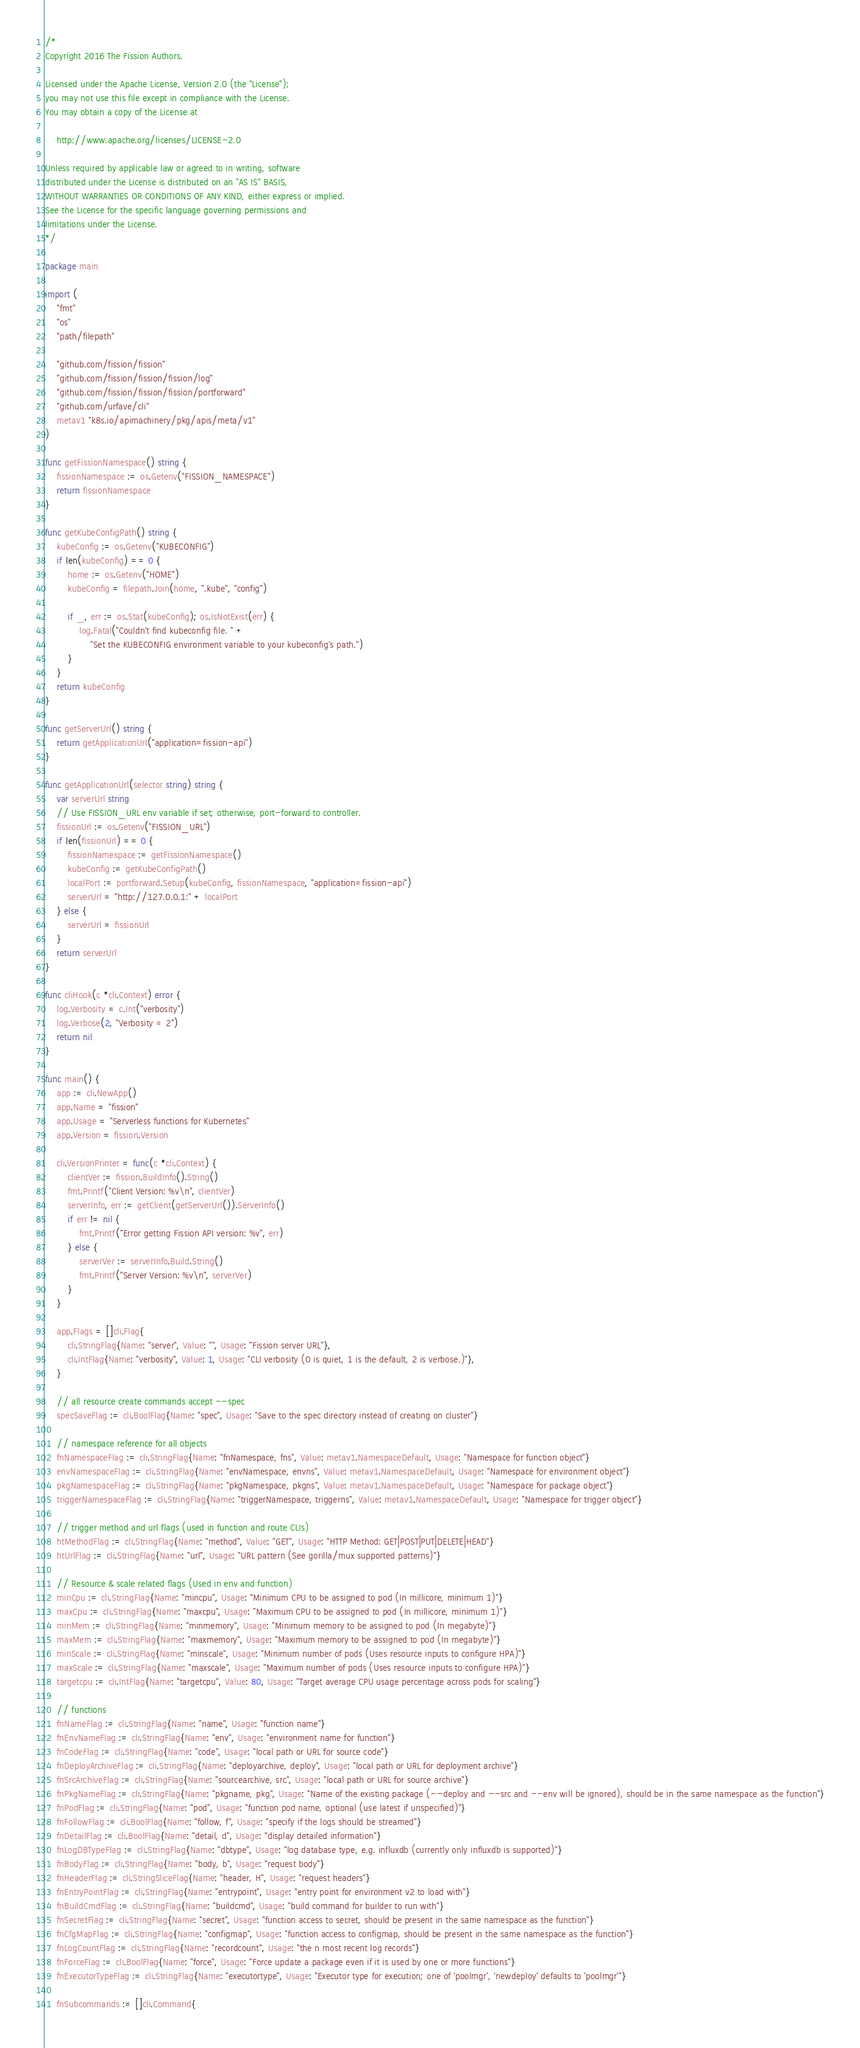<code> <loc_0><loc_0><loc_500><loc_500><_Go_>/*
Copyright 2016 The Fission Authors.

Licensed under the Apache License, Version 2.0 (the "License");
you may not use this file except in compliance with the License.
You may obtain a copy of the License at

    http://www.apache.org/licenses/LICENSE-2.0

Unless required by applicable law or agreed to in writing, software
distributed under the License is distributed on an "AS IS" BASIS,
WITHOUT WARRANTIES OR CONDITIONS OF ANY KIND, either express or implied.
See the License for the specific language governing permissions and
limitations under the License.
*/

package main

import (
	"fmt"
	"os"
	"path/filepath"

	"github.com/fission/fission"
	"github.com/fission/fission/fission/log"
	"github.com/fission/fission/fission/portforward"
	"github.com/urfave/cli"
	metav1 "k8s.io/apimachinery/pkg/apis/meta/v1"
)

func getFissionNamespace() string {
	fissionNamespace := os.Getenv("FISSION_NAMESPACE")
	return fissionNamespace
}

func getKubeConfigPath() string {
	kubeConfig := os.Getenv("KUBECONFIG")
	if len(kubeConfig) == 0 {
		home := os.Getenv("HOME")
		kubeConfig = filepath.Join(home, ".kube", "config")

		if _, err := os.Stat(kubeConfig); os.IsNotExist(err) {
			log.Fatal("Couldn't find kubeconfig file. " +
				"Set the KUBECONFIG environment variable to your kubeconfig's path.")
		}
	}
	return kubeConfig
}

func getServerUrl() string {
	return getApplicationUrl("application=fission-api")
}

func getApplicationUrl(selector string) string {
	var serverUrl string
	// Use FISSION_URL env variable if set; otherwise, port-forward to controller.
	fissionUrl := os.Getenv("FISSION_URL")
	if len(fissionUrl) == 0 {
		fissionNamespace := getFissionNamespace()
		kubeConfig := getKubeConfigPath()
		localPort := portforward.Setup(kubeConfig, fissionNamespace, "application=fission-api")
		serverUrl = "http://127.0.0.1:" + localPort
	} else {
		serverUrl = fissionUrl
	}
	return serverUrl
}

func cliHook(c *cli.Context) error {
	log.Verbosity = c.Int("verbosity")
	log.Verbose(2, "Verbosity = 2")
	return nil
}

func main() {
	app := cli.NewApp()
	app.Name = "fission"
	app.Usage = "Serverless functions for Kubernetes"
	app.Version = fission.Version

	cli.VersionPrinter = func(c *cli.Context) {
		clientVer := fission.BuildInfo().String()
		fmt.Printf("Client Version: %v\n", clientVer)
		serverInfo, err := getClient(getServerUrl()).ServerInfo()
		if err != nil {
			fmt.Printf("Error getting Fission API version: %v", err)
		} else {
			serverVer := serverInfo.Build.String()
			fmt.Printf("Server Version: %v\n", serverVer)
		}
	}

	app.Flags = []cli.Flag{
		cli.StringFlag{Name: "server", Value: "", Usage: "Fission server URL"},
		cli.IntFlag{Name: "verbosity", Value: 1, Usage: "CLI verbosity (0 is quiet, 1 is the default, 2 is verbose.)"},
	}

	// all resource create commands accept --spec
	specSaveFlag := cli.BoolFlag{Name: "spec", Usage: "Save to the spec directory instead of creating on cluster"}

	// namespace reference for all objects
	fnNamespaceFlag := cli.StringFlag{Name: "fnNamespace, fns", Value: metav1.NamespaceDefault, Usage: "Namespace for function object"}
	envNamespaceFlag := cli.StringFlag{Name: "envNamespace, envns", Value: metav1.NamespaceDefault, Usage: "Namespace for environment object"}
	pkgNamespaceFlag := cli.StringFlag{Name: "pkgNamespace, pkgns", Value: metav1.NamespaceDefault, Usage: "Namespace for package object"}
	triggerNamespaceFlag := cli.StringFlag{Name: "triggerNamespace, triggerns", Value: metav1.NamespaceDefault, Usage: "Namespace for trigger object"}

	// trigger method and url flags (used in function and route CLIs)
	htMethodFlag := cli.StringFlag{Name: "method", Value: "GET", Usage: "HTTP Method: GET|POST|PUT|DELETE|HEAD"}
	htUrlFlag := cli.StringFlag{Name: "url", Usage: "URL pattern (See gorilla/mux supported patterns)"}

	// Resource & scale related flags (Used in env and function)
	minCpu := cli.StringFlag{Name: "mincpu", Usage: "Minimum CPU to be assigned to pod (In millicore, minimum 1)"}
	maxCpu := cli.StringFlag{Name: "maxcpu", Usage: "Maximum CPU to be assigned to pod (In millicore, minimum 1)"}
	minMem := cli.StringFlag{Name: "minmemory", Usage: "Minimum memory to be assigned to pod (In megabyte)"}
	maxMem := cli.StringFlag{Name: "maxmemory", Usage: "Maximum memory to be assigned to pod (In megabyte)"}
	minScale := cli.StringFlag{Name: "minscale", Usage: "Minimum number of pods (Uses resource inputs to configure HPA)"}
	maxScale := cli.StringFlag{Name: "maxscale", Usage: "Maximum number of pods (Uses resource inputs to configure HPA)"}
	targetcpu := cli.IntFlag{Name: "targetcpu", Value: 80, Usage: "Target average CPU usage percentage across pods for scaling"}

	// functions
	fnNameFlag := cli.StringFlag{Name: "name", Usage: "function name"}
	fnEnvNameFlag := cli.StringFlag{Name: "env", Usage: "environment name for function"}
	fnCodeFlag := cli.StringFlag{Name: "code", Usage: "local path or URL for source code"}
	fnDeployArchiveFlag := cli.StringFlag{Name: "deployarchive, deploy", Usage: "local path or URL for deployment archive"}
	fnSrcArchiveFlag := cli.StringFlag{Name: "sourcearchive, src", Usage: "local path or URL for source archive"}
	fnPkgNameFlag := cli.StringFlag{Name: "pkgname, pkg", Usage: "Name of the existing package (--deploy and --src and --env will be ignored), should be in the same namespace as the function"}
	fnPodFlag := cli.StringFlag{Name: "pod", Usage: "function pod name, optional (use latest if unspecified)"}
	fnFollowFlag := cli.BoolFlag{Name: "follow, f", Usage: "specify if the logs should be streamed"}
	fnDetailFlag := cli.BoolFlag{Name: "detail, d", Usage: "display detailed information"}
	fnLogDBTypeFlag := cli.StringFlag{Name: "dbtype", Usage: "log database type, e.g. influxdb (currently only influxdb is supported)"}
	fnBodyFlag := cli.StringFlag{Name: "body, b", Usage: "request body"}
	fnHeaderFlag := cli.StringSliceFlag{Name: "header, H", Usage: "request headers"}
	fnEntryPointFlag := cli.StringFlag{Name: "entrypoint", Usage: "entry point for environment v2 to load with"}
	fnBuildCmdFlag := cli.StringFlag{Name: "buildcmd", Usage: "build command for builder to run with"}
	fnSecretFlag := cli.StringFlag{Name: "secret", Usage: "function access to secret, should be present in the same namespace as the function"}
	fnCfgMapFlag := cli.StringFlag{Name: "configmap", Usage: "function access to configmap, should be present in the same namespace as the function"}
	fnLogCountFlag := cli.StringFlag{Name: "recordcount", Usage: "the n most recent log records"}
	fnForceFlag := cli.BoolFlag{Name: "force", Usage: "Force update a package even if it is used by one or more functions"}
	fnExecutorTypeFlag := cli.StringFlag{Name: "executortype", Usage: "Executor type for execution; one of 'poolmgr', 'newdeploy' defaults to 'poolmgr'"}

	fnSubcommands := []cli.Command{</code> 